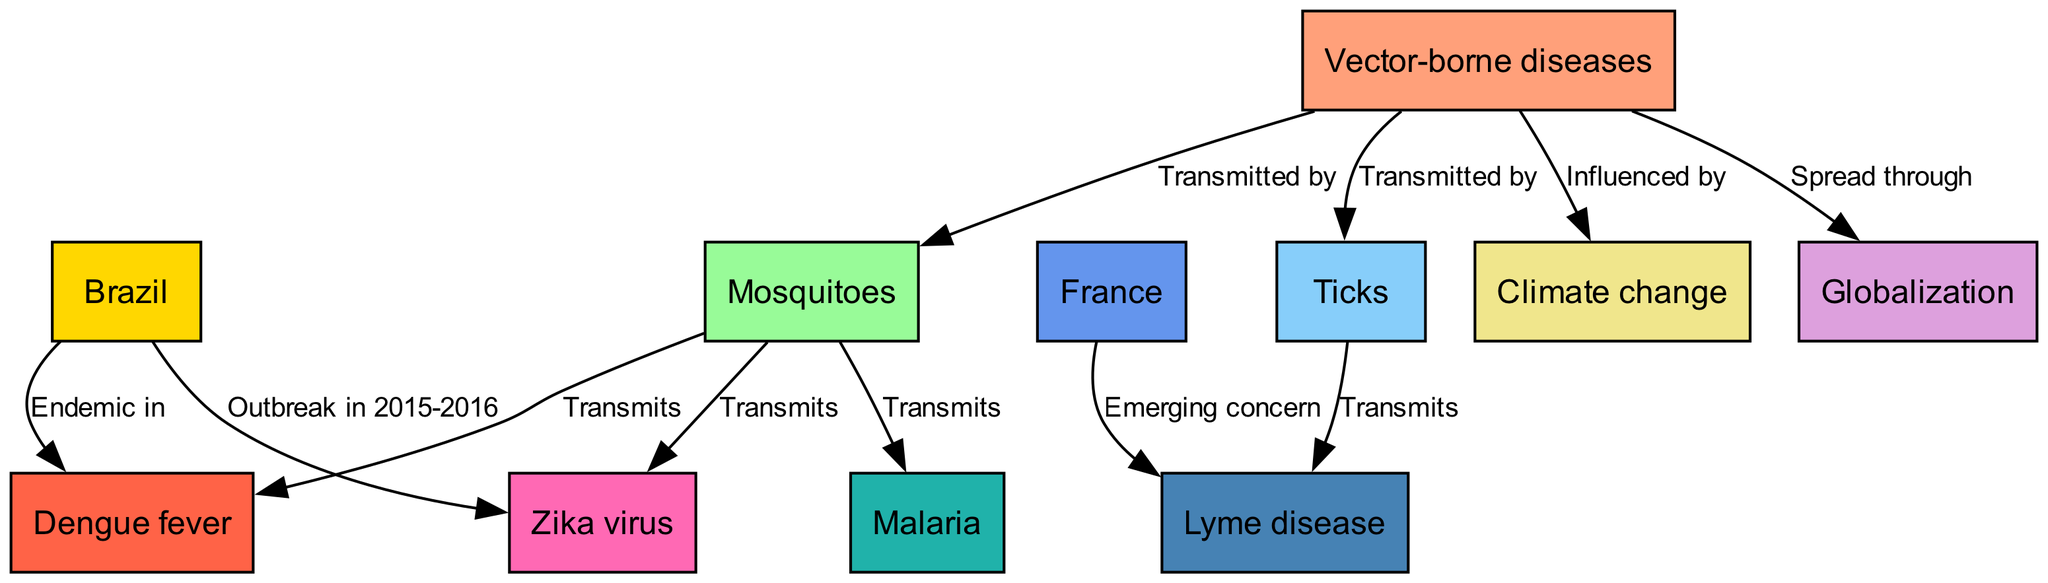What types of vectors transmit diseases according to the diagram? The diagram shows two types of vectors that transmit diseases: mosquitoes and ticks. These nodes are directly connected to the main node "Vector-borne diseases," indicating their roles in transmission.
Answer: Mosquitoes, Ticks Which disease is transmitted by mosquitoes? The diagram has an edge labeled "Transmits" from the "Mosquitoes" node to the "Dengue fever," "Malaria," and "Zika virus" nodes. By focusing on the connections, we can identify that several diseases are transmitted by mosquitoes.
Answer: Dengue fever, Malaria, Zika virus How many diseases does "Ticks" transmit according to the map? There is only one connection from "Ticks" to "Lyme disease," indicating it is the sole disease indicated in this context that is transmitted by ticks. Therefore, the number of diseases is simple to count.
Answer: 1 Which factor influences the spread of vector-borne diseases? Looking at the connections in the diagram, "Climate change" has an edge labeled "Influenced by" connected to "Vector-borne diseases," implying it is a significant factor that influences the spread of these diseases.
Answer: Climate change Which country is endemic for Dengue fever according to this diagram? The diagram clearly indicates a relationship from "Brazil" to "Dengue fever" with the label "Endemic in," specifically pointing out that Dengue fever is prevalent in Brazil.
Answer: Brazil What disease is an emerging concern in France? In the diagram, there is an edge from "France" to "Lyme disease" labeled "Emerging concern," clarifying that Lyme disease is underlined as a new concern in France.
Answer: Lyme disease What connects globalization with vector-borne diseases? The "Globalization" node has an edge labeled "Spread through" connected to "Vector-borne diseases," indicating that globalization is a mechanism through which these diseases spread globally.
Answer: Spread through How many diseases are shown in the diagram? By counting the disease nodes in the diagram, we find four distinct disease nodes: "Dengue fever," "Malaria," "Zika virus," and "Lyme disease." Thus, the total count of diseases represented is straightforward.
Answer: 4 